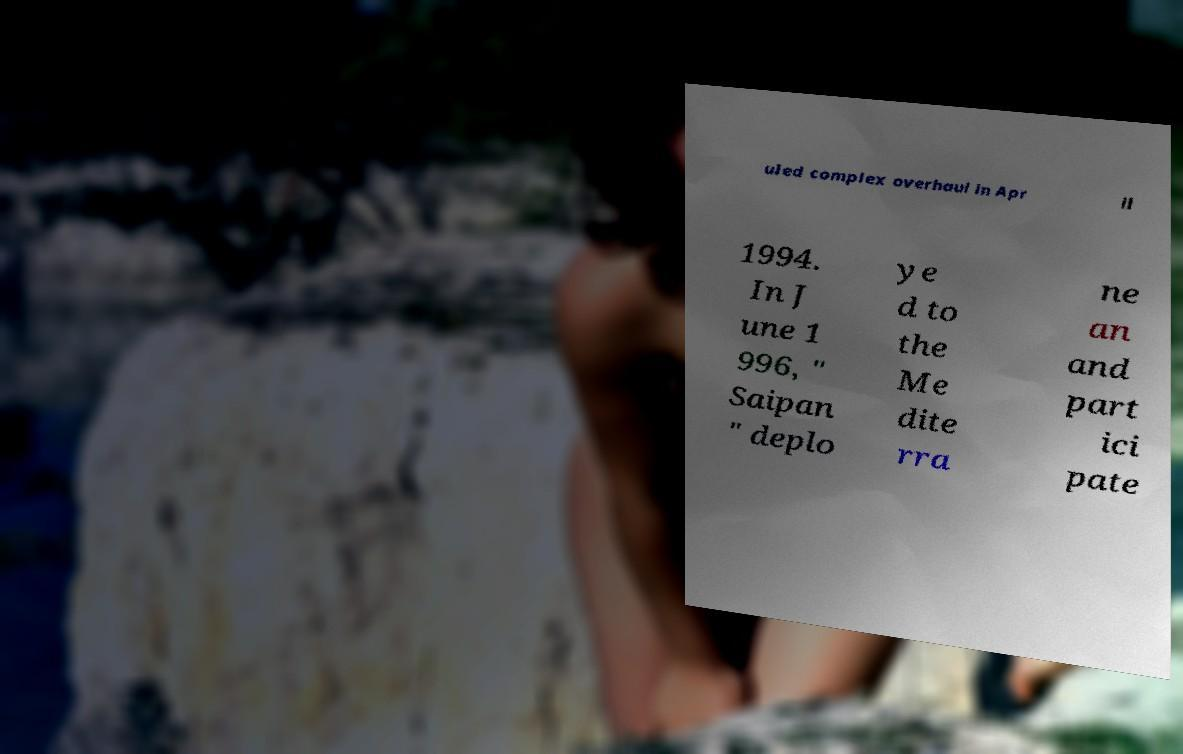Could you extract and type out the text from this image? uled complex overhaul in Apr il 1994. In J une 1 996, " Saipan " deplo ye d to the Me dite rra ne an and part ici pate 